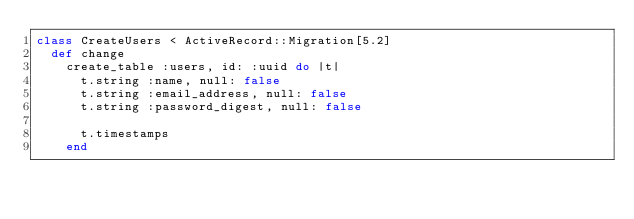<code> <loc_0><loc_0><loc_500><loc_500><_Ruby_>class CreateUsers < ActiveRecord::Migration[5.2]
  def change
    create_table :users, id: :uuid do |t|
      t.string :name, null: false
      t.string :email_address, null: false
      t.string :password_digest, null: false

      t.timestamps
    end</code> 